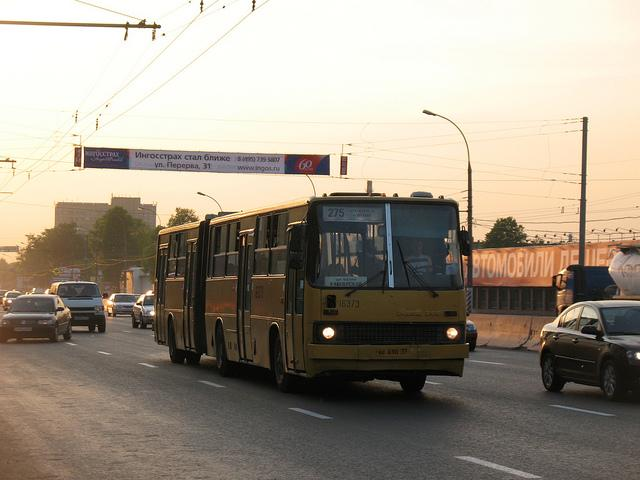What time of day does the bus drive in here? evening 